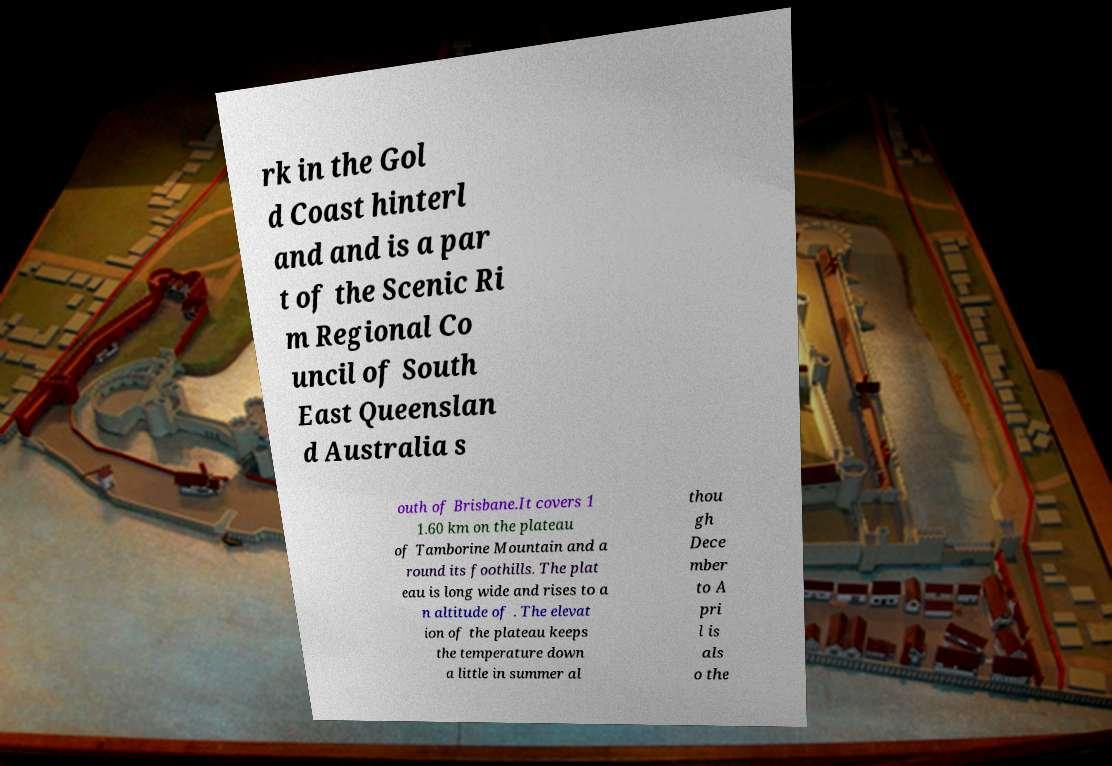For documentation purposes, I need the text within this image transcribed. Could you provide that? rk in the Gol d Coast hinterl and and is a par t of the Scenic Ri m Regional Co uncil of South East Queenslan d Australia s outh of Brisbane.It covers 1 1.60 km on the plateau of Tamborine Mountain and a round its foothills. The plat eau is long wide and rises to a n altitude of . The elevat ion of the plateau keeps the temperature down a little in summer al thou gh Dece mber to A pri l is als o the 